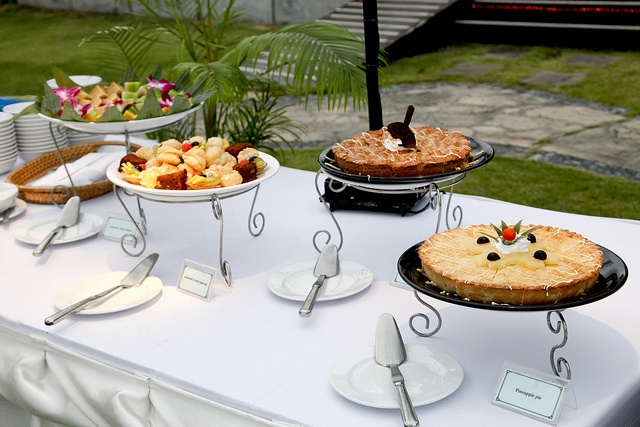Describe the objects in this image and their specific colors. I can see dining table in lightgray, black, darkgray, and gray tones, potted plant in black, darkgreen, and gray tones, cake in black, tan, maroon, and olive tones, pizza in black, tan, maroon, and red tones, and spoon in black, lightgray, darkgray, and gray tones in this image. 